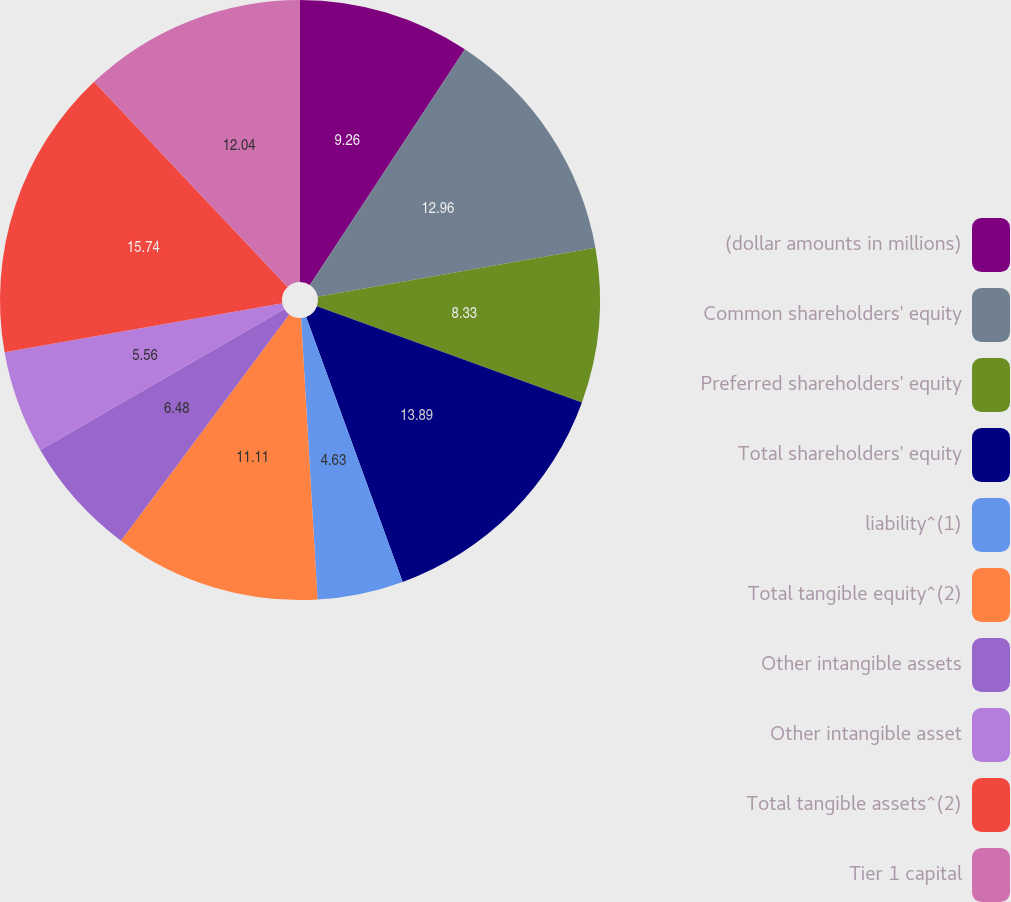Convert chart. <chart><loc_0><loc_0><loc_500><loc_500><pie_chart><fcel>(dollar amounts in millions)<fcel>Common shareholders' equity<fcel>Preferred shareholders' equity<fcel>Total shareholders' equity<fcel>liability^(1)<fcel>Total tangible equity^(2)<fcel>Other intangible assets<fcel>Other intangible asset<fcel>Total tangible assets^(2)<fcel>Tier 1 capital<nl><fcel>9.26%<fcel>12.96%<fcel>8.33%<fcel>13.89%<fcel>4.63%<fcel>11.11%<fcel>6.48%<fcel>5.56%<fcel>15.74%<fcel>12.04%<nl></chart> 